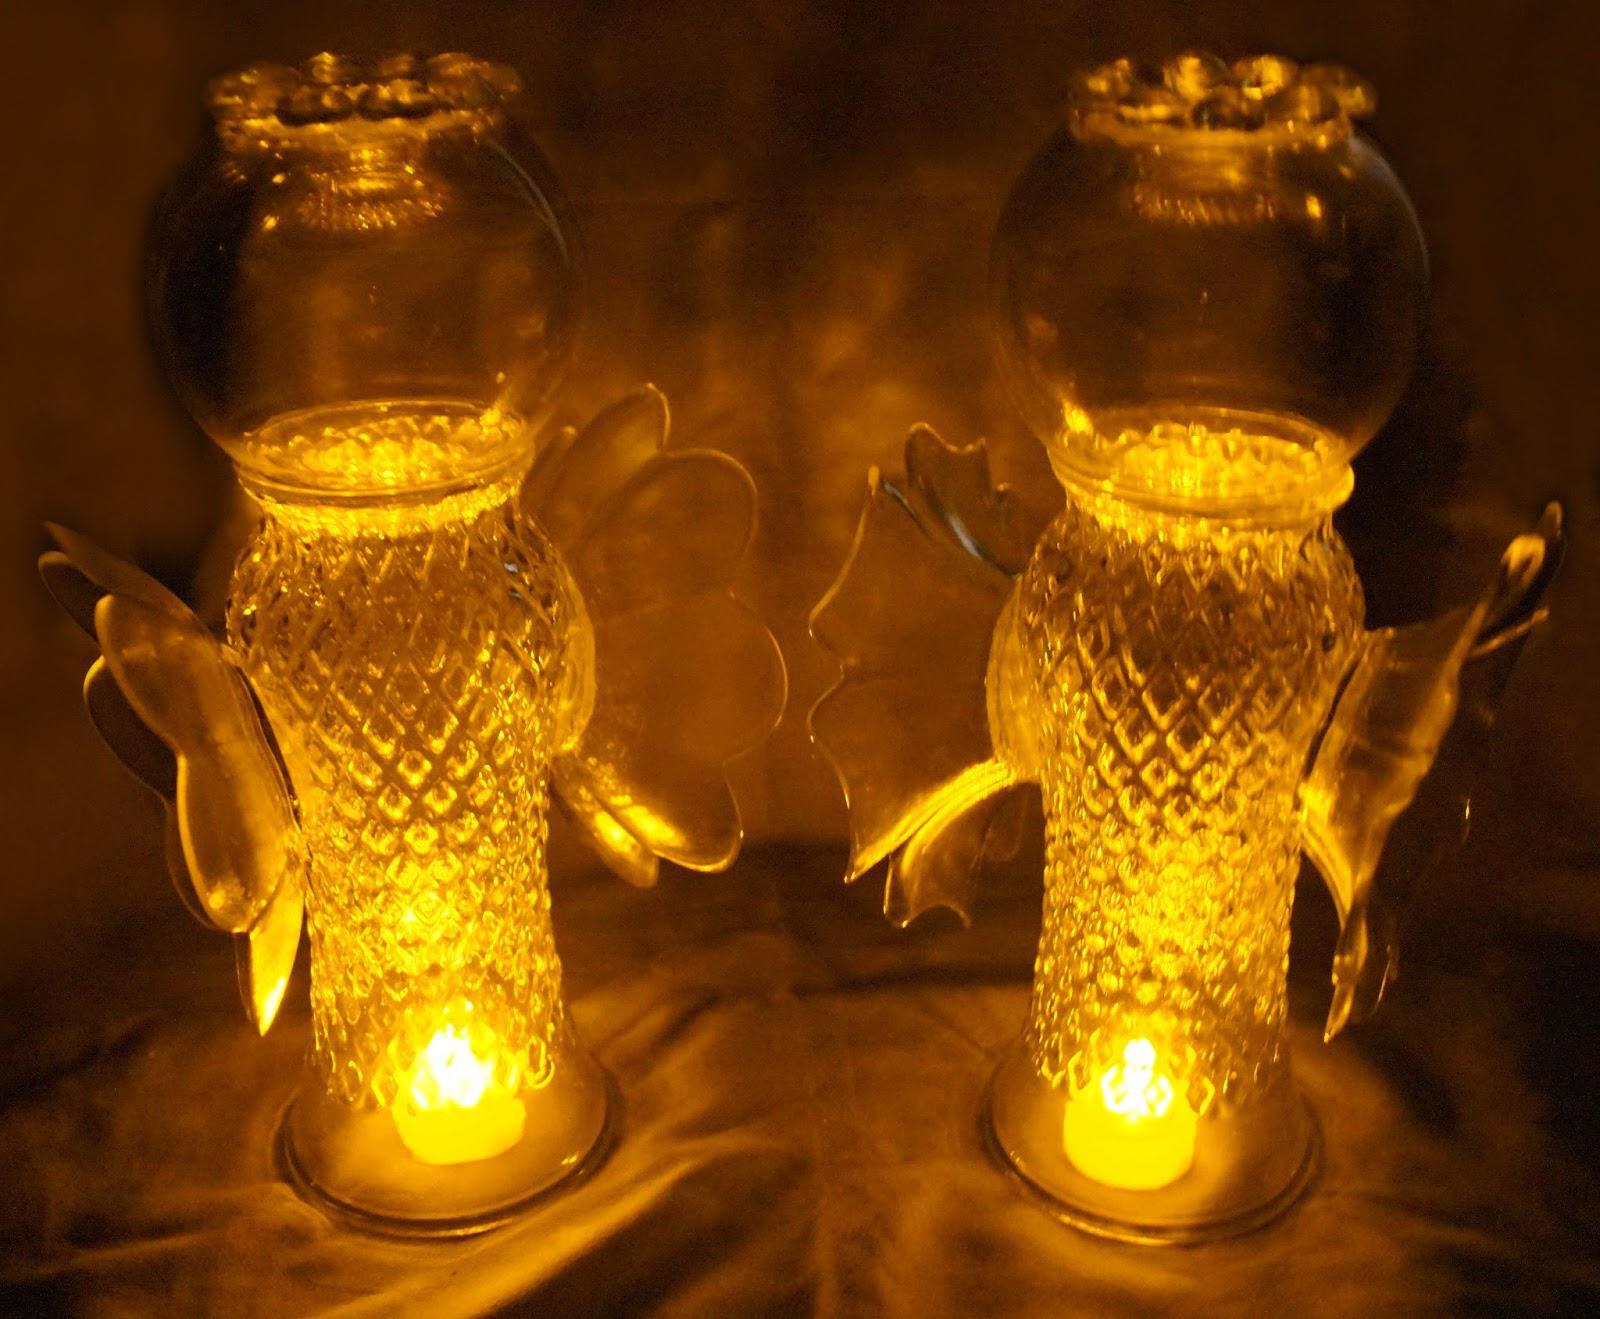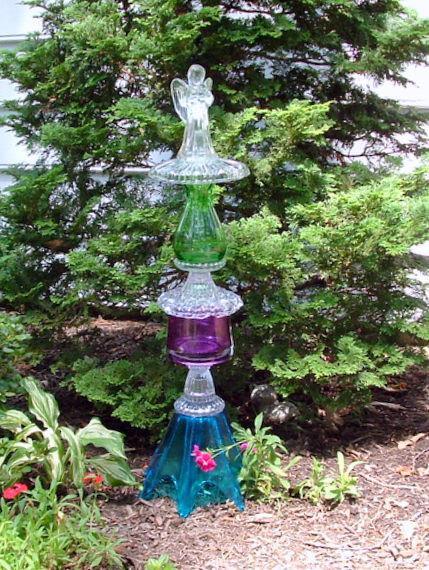The first image is the image on the left, the second image is the image on the right. Considering the images on both sides, is "One image features a tower of stacked glass vases and pedestals in various colors, and the stacked glassware does not combine to form a human-like figure." valid? Answer yes or no. Yes. The first image is the image on the left, the second image is the image on the right. Considering the images on both sides, is "In at least one image there is a glass angel looking vase that is touch leaves and dirt on the ground." valid? Answer yes or no. No. 